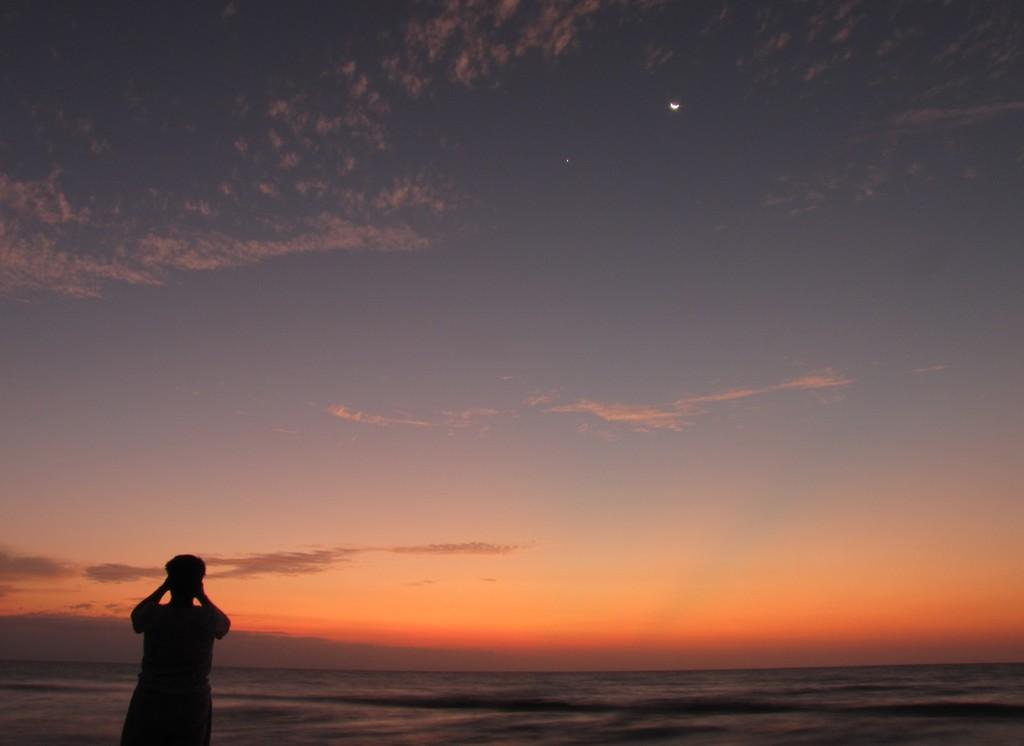What can be seen at the top of the image? The sky is visible in the image. Where is the person located in the image? The person is standing on the left side bottom of the image. What type of toy can be seen on the board in the image? There is no toy or board present in the image; it only features a person and the sky. 